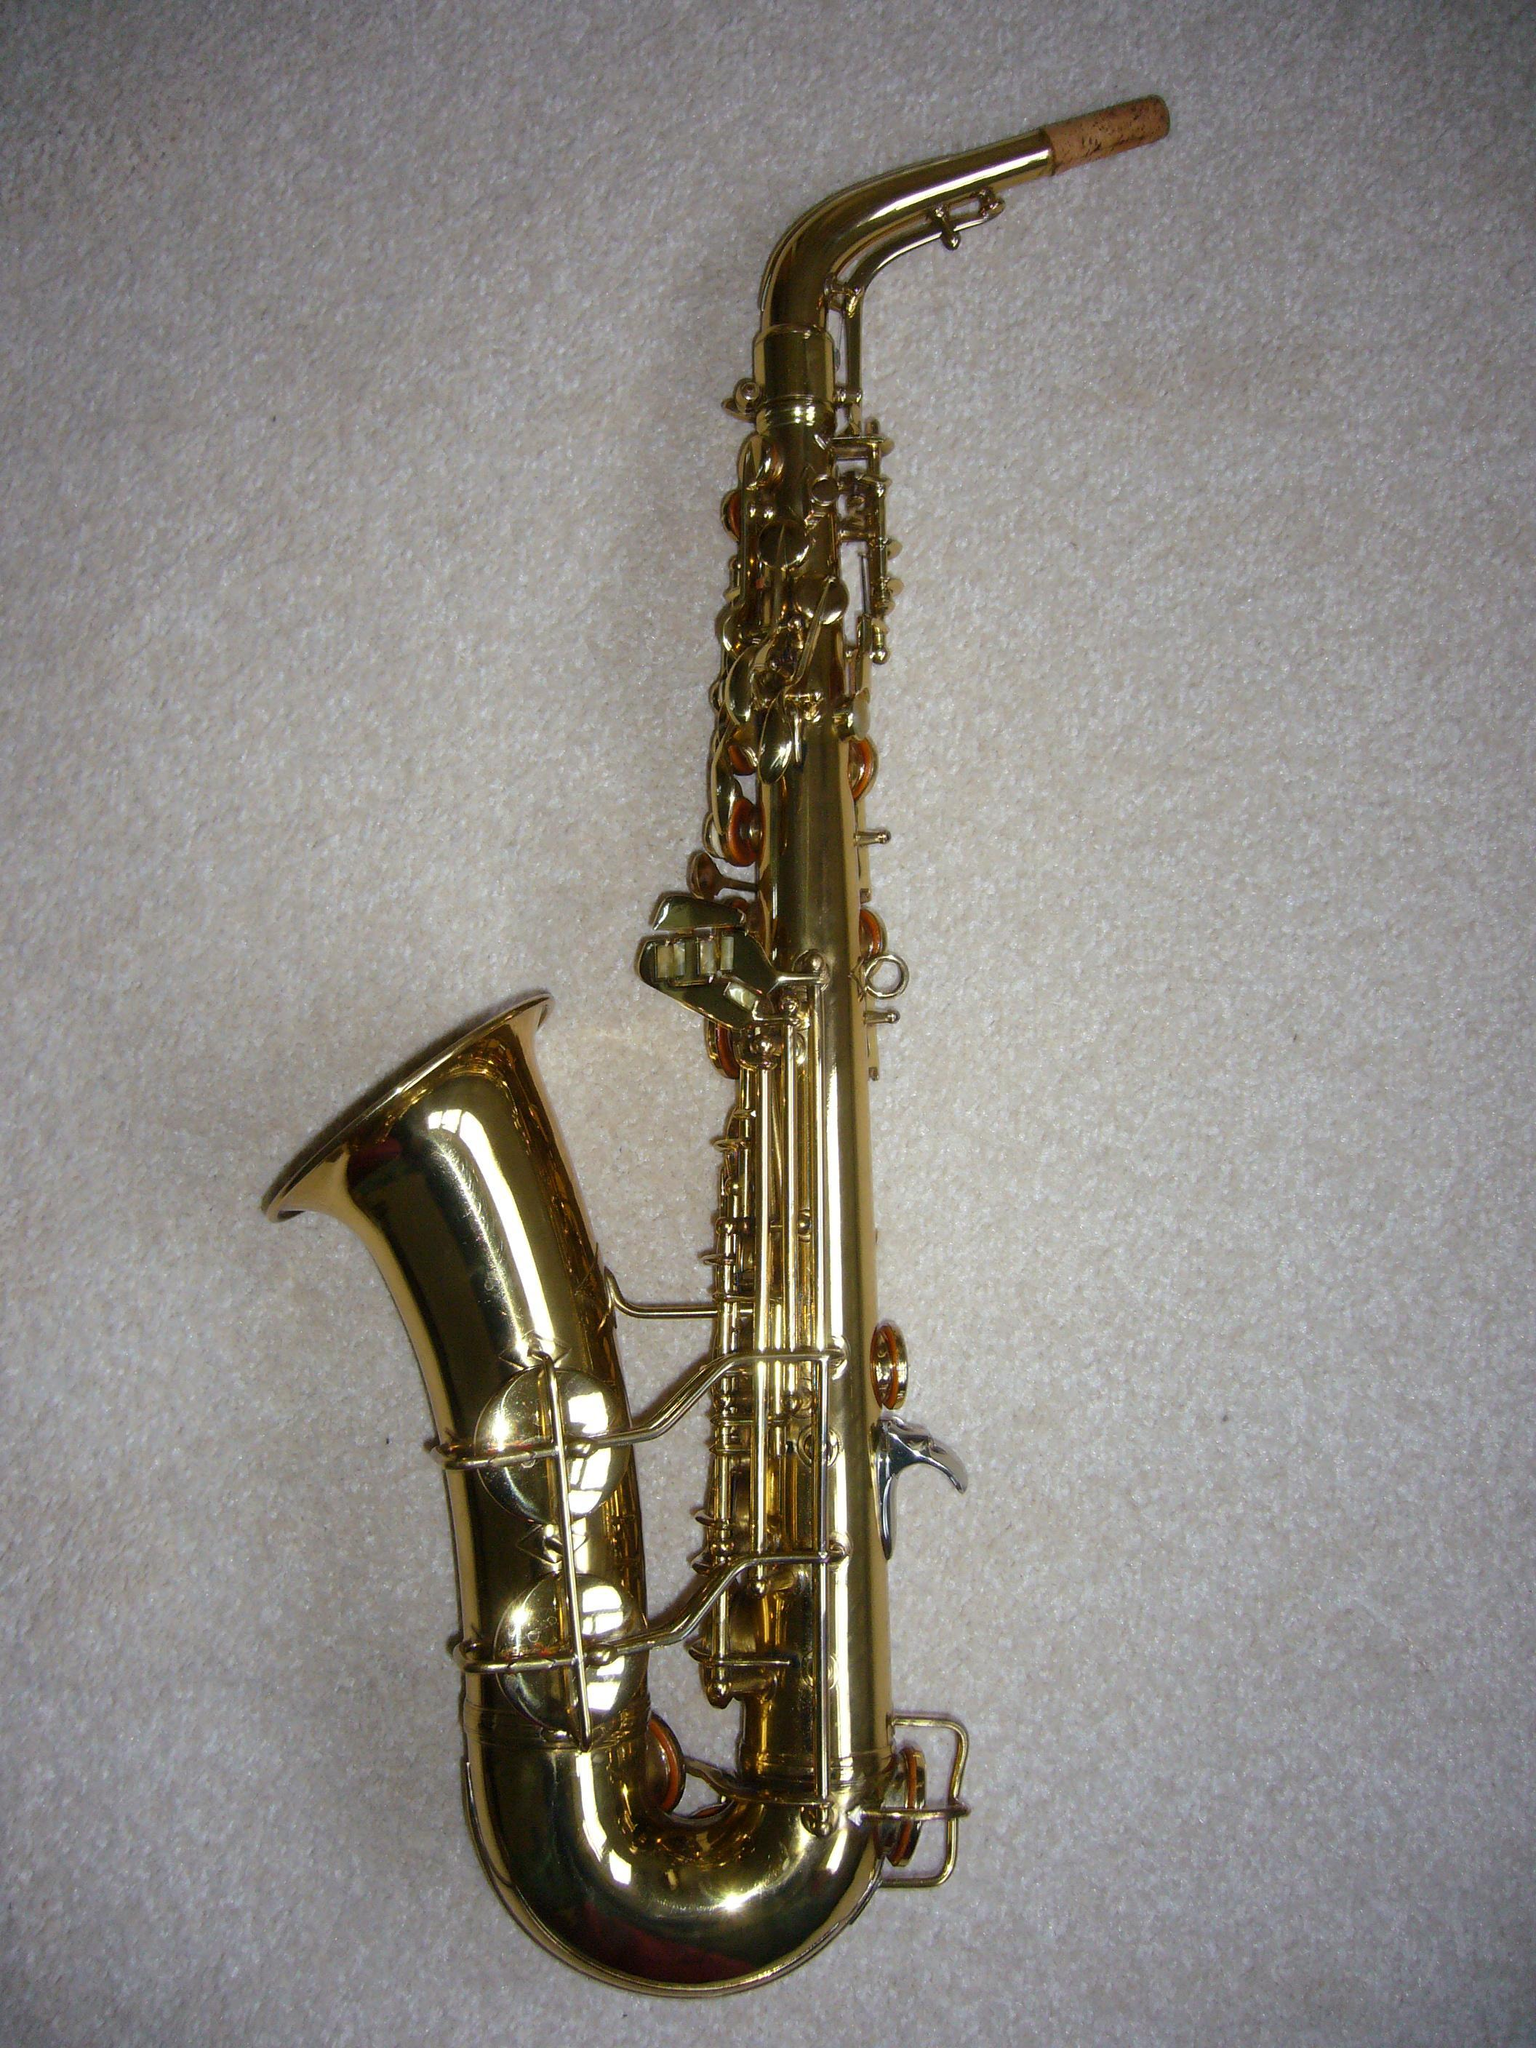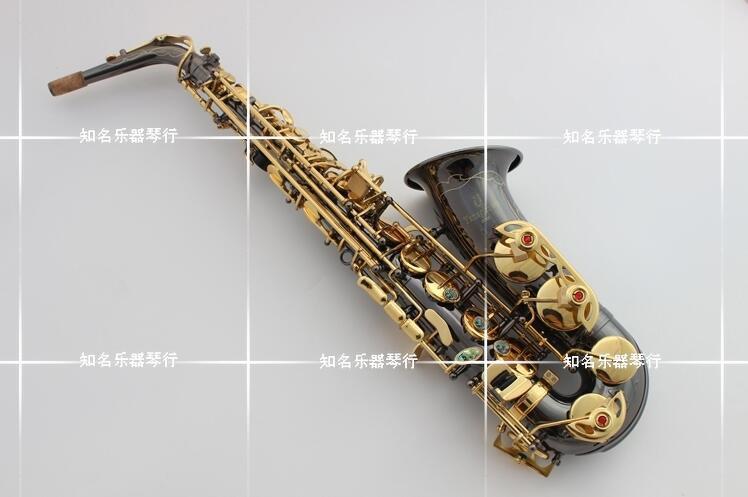The first image is the image on the left, the second image is the image on the right. For the images shown, is this caption "An image shows an instrument with a very dark finish and brass works." true? Answer yes or no. Yes. 